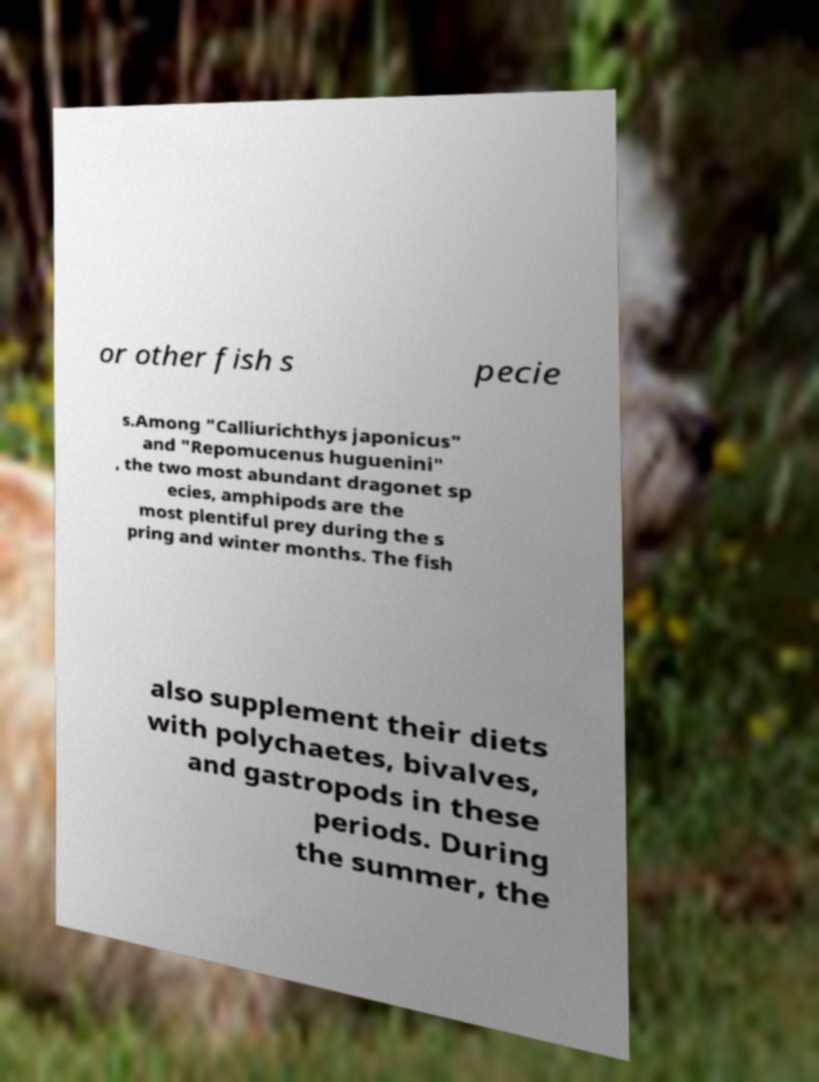Please read and relay the text visible in this image. What does it say? or other fish s pecie s.Among "Calliurichthys japonicus" and "Repomucenus huguenini" , the two most abundant dragonet sp ecies, amphipods are the most plentiful prey during the s pring and winter months. The fish also supplement their diets with polychaetes, bivalves, and gastropods in these periods. During the summer, the 